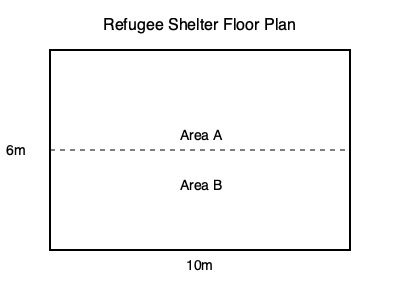A rectangular refugee shelter has dimensions of 10m x 6m, as shown in the floor plan. The shelter is divided into two areas: Area A for sleeping and Area B for common space. If each person requires 3 square meters of sleeping space, and Area A occupies 60% of the total shelter area, what is the maximum number of refugees that can be accommodated in the sleeping area? To solve this problem, let's follow these steps:

1. Calculate the total area of the shelter:
   $$ \text{Total Area} = \text{Length} \times \text{Width} = 10\text{m} \times 6\text{m} = 60\text{m}^2 $$

2. Calculate the area of the sleeping space (Area A):
   $$ \text{Area A} = 60\% \text{ of Total Area} = 0.60 \times 60\text{m}^2 = 36\text{m}^2 $$

3. Calculate the number of refugees that can be accommodated:
   $$ \text{Number of Refugees} = \frac{\text{Area A}}{\text{Space per person}} = \frac{36\text{m}^2}{3\text{m}^2\text{ per person}} = 12 $$

Therefore, the maximum number of refugees that can be accommodated in the sleeping area is 12.
Answer: 12 refugees 